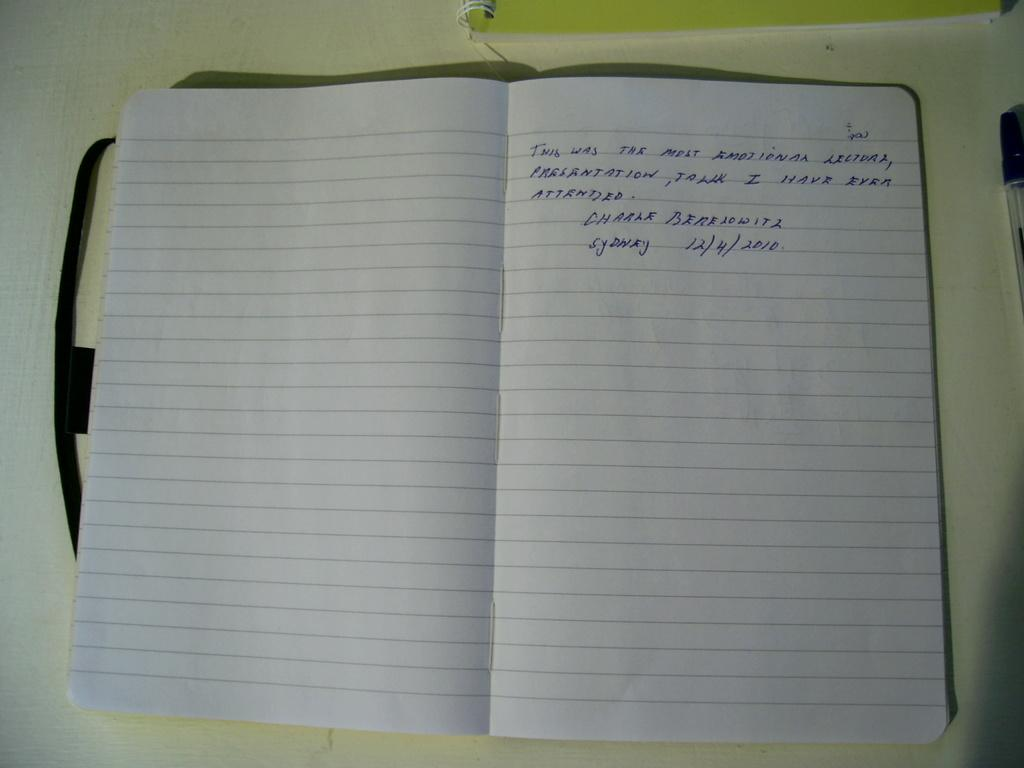<image>
Give a short and clear explanation of the subsequent image. an open notebook saying it was the most emotional lecture presentation talk they have attended, signed Charle Berelowitz Sydney 12/4/2010. 